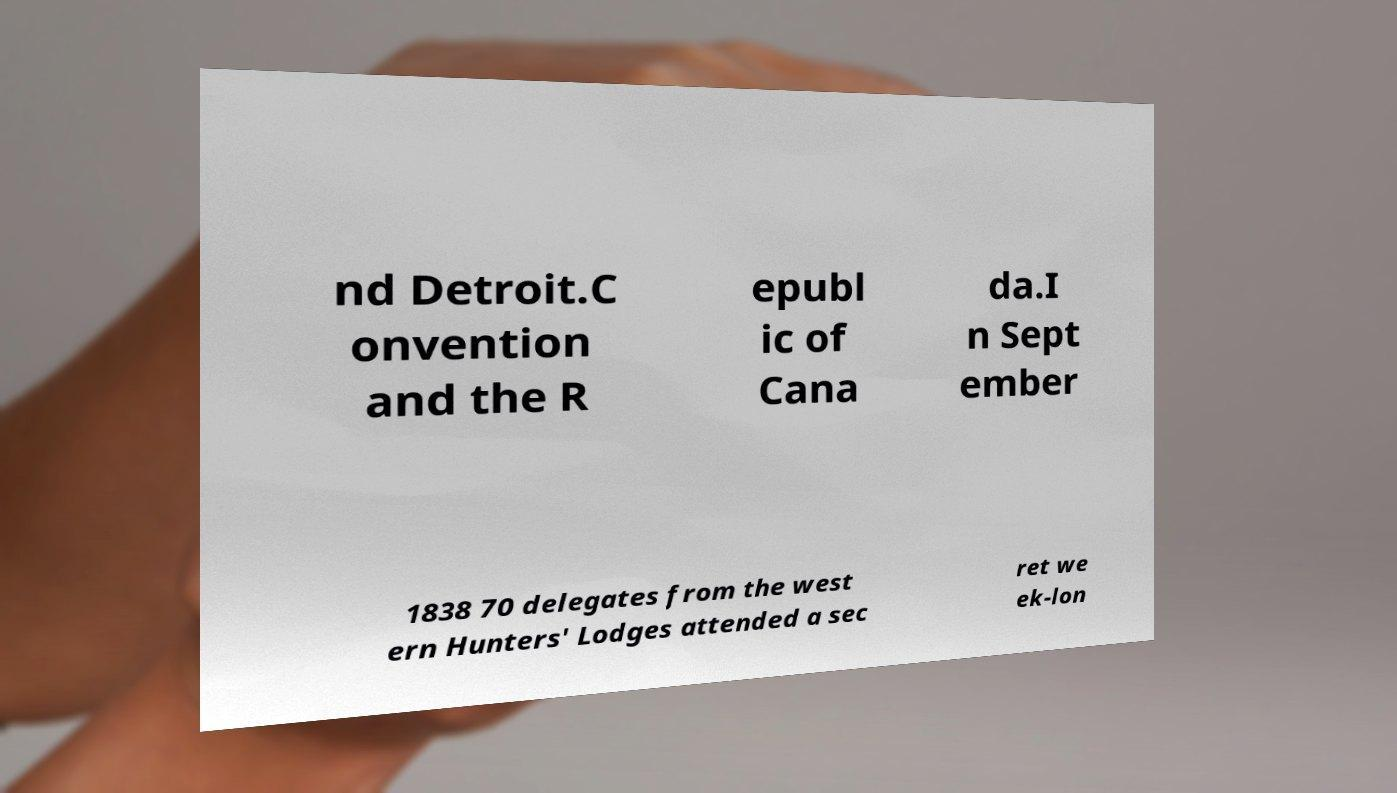What messages or text are displayed in this image? I need them in a readable, typed format. nd Detroit.C onvention and the R epubl ic of Cana da.I n Sept ember 1838 70 delegates from the west ern Hunters' Lodges attended a sec ret we ek-lon 